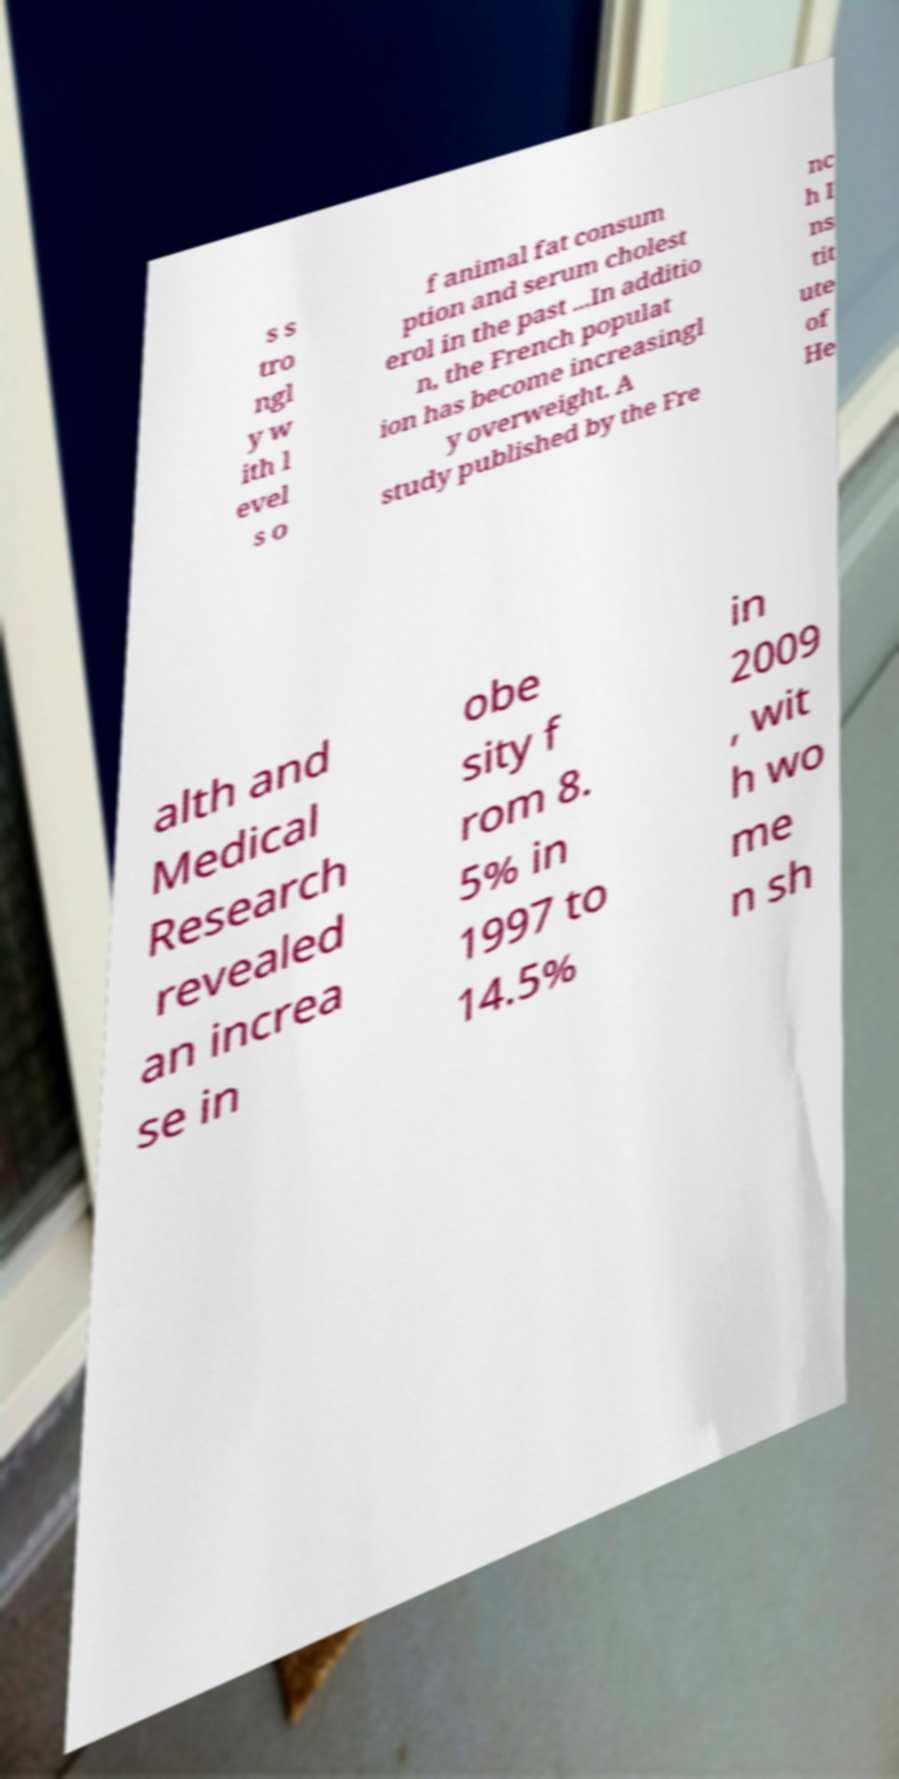Please identify and transcribe the text found in this image. s s tro ngl y w ith l evel s o f animal fat consum ption and serum cholest erol in the past ...In additio n, the French populat ion has become increasingl y overweight. A study published by the Fre nc h I ns tit ute of He alth and Medical Research revealed an increa se in obe sity f rom 8. 5% in 1997 to 14.5% in 2009 , wit h wo me n sh 